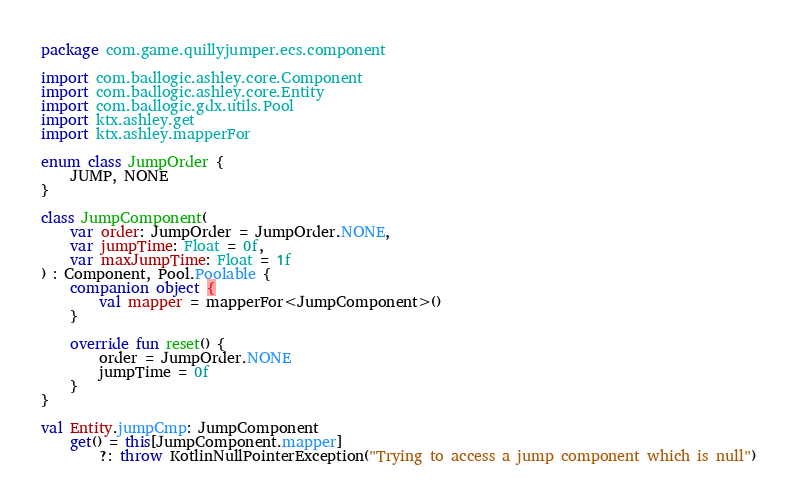Convert code to text. <code><loc_0><loc_0><loc_500><loc_500><_Kotlin_>package com.game.quillyjumper.ecs.component

import com.badlogic.ashley.core.Component
import com.badlogic.ashley.core.Entity
import com.badlogic.gdx.utils.Pool
import ktx.ashley.get
import ktx.ashley.mapperFor

enum class JumpOrder {
    JUMP, NONE
}

class JumpComponent(
    var order: JumpOrder = JumpOrder.NONE,
    var jumpTime: Float = 0f,
    var maxJumpTime: Float = 1f
) : Component, Pool.Poolable {
    companion object {
        val mapper = mapperFor<JumpComponent>()
    }

    override fun reset() {
        order = JumpOrder.NONE
        jumpTime = 0f
    }
}

val Entity.jumpCmp: JumpComponent
    get() = this[JumpComponent.mapper]
        ?: throw KotlinNullPointerException("Trying to access a jump component which is null")
</code> 